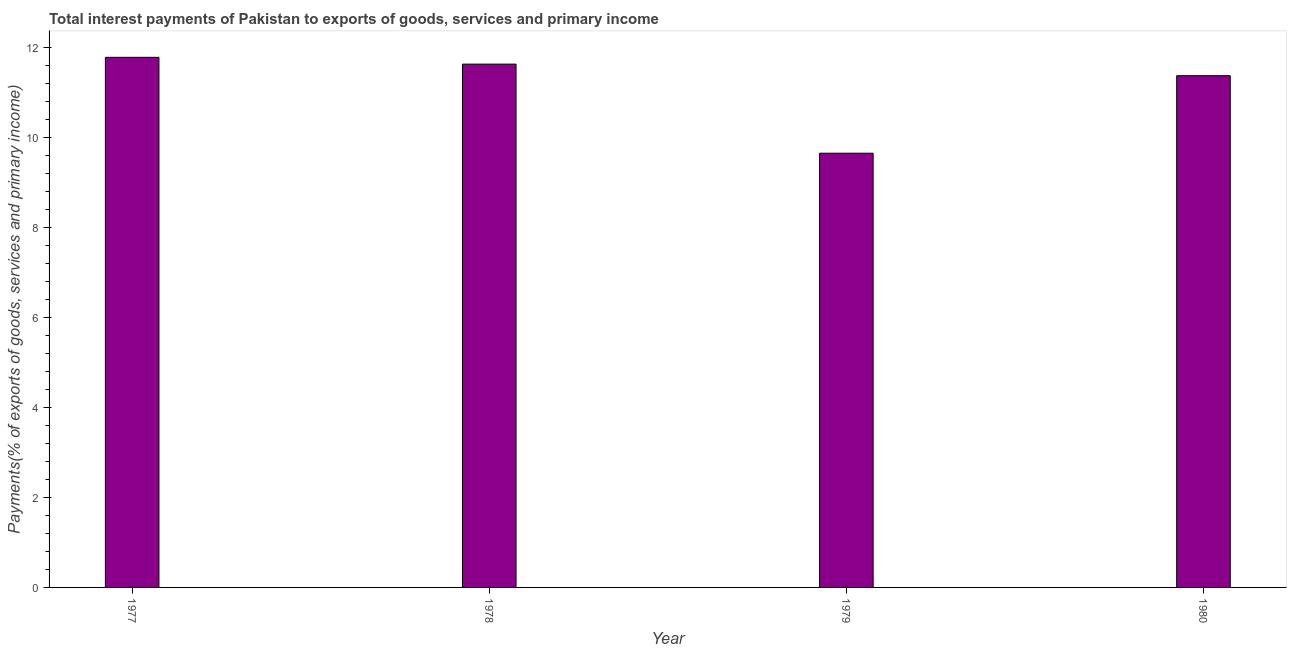Does the graph contain any zero values?
Ensure brevity in your answer.  No. Does the graph contain grids?
Make the answer very short. No. What is the title of the graph?
Your answer should be compact. Total interest payments of Pakistan to exports of goods, services and primary income. What is the label or title of the X-axis?
Make the answer very short. Year. What is the label or title of the Y-axis?
Provide a succinct answer. Payments(% of exports of goods, services and primary income). What is the total interest payments on external debt in 1978?
Your answer should be very brief. 11.62. Across all years, what is the maximum total interest payments on external debt?
Ensure brevity in your answer.  11.77. Across all years, what is the minimum total interest payments on external debt?
Ensure brevity in your answer.  9.64. In which year was the total interest payments on external debt minimum?
Make the answer very short. 1979. What is the sum of the total interest payments on external debt?
Provide a succinct answer. 44.41. What is the difference between the total interest payments on external debt in 1978 and 1980?
Your answer should be compact. 0.26. What is the average total interest payments on external debt per year?
Ensure brevity in your answer.  11.1. What is the median total interest payments on external debt?
Provide a short and direct response. 11.49. Do a majority of the years between 1977 and 1979 (inclusive) have total interest payments on external debt greater than 2 %?
Make the answer very short. Yes. What is the difference between the highest and the second highest total interest payments on external debt?
Your answer should be very brief. 0.15. What is the difference between the highest and the lowest total interest payments on external debt?
Give a very brief answer. 2.13. How many bars are there?
Provide a succinct answer. 4. What is the difference between two consecutive major ticks on the Y-axis?
Provide a short and direct response. 2. What is the Payments(% of exports of goods, services and primary income) of 1977?
Your response must be concise. 11.77. What is the Payments(% of exports of goods, services and primary income) of 1978?
Ensure brevity in your answer.  11.62. What is the Payments(% of exports of goods, services and primary income) of 1979?
Ensure brevity in your answer.  9.64. What is the Payments(% of exports of goods, services and primary income) in 1980?
Provide a short and direct response. 11.37. What is the difference between the Payments(% of exports of goods, services and primary income) in 1977 and 1978?
Ensure brevity in your answer.  0.15. What is the difference between the Payments(% of exports of goods, services and primary income) in 1977 and 1979?
Your answer should be compact. 2.13. What is the difference between the Payments(% of exports of goods, services and primary income) in 1977 and 1980?
Provide a short and direct response. 0.41. What is the difference between the Payments(% of exports of goods, services and primary income) in 1978 and 1979?
Your response must be concise. 1.98. What is the difference between the Payments(% of exports of goods, services and primary income) in 1978 and 1980?
Provide a succinct answer. 0.26. What is the difference between the Payments(% of exports of goods, services and primary income) in 1979 and 1980?
Your answer should be compact. -1.72. What is the ratio of the Payments(% of exports of goods, services and primary income) in 1977 to that in 1978?
Your answer should be very brief. 1.01. What is the ratio of the Payments(% of exports of goods, services and primary income) in 1977 to that in 1979?
Your answer should be very brief. 1.22. What is the ratio of the Payments(% of exports of goods, services and primary income) in 1977 to that in 1980?
Give a very brief answer. 1.04. What is the ratio of the Payments(% of exports of goods, services and primary income) in 1978 to that in 1979?
Make the answer very short. 1.21. What is the ratio of the Payments(% of exports of goods, services and primary income) in 1979 to that in 1980?
Keep it short and to the point. 0.85. 